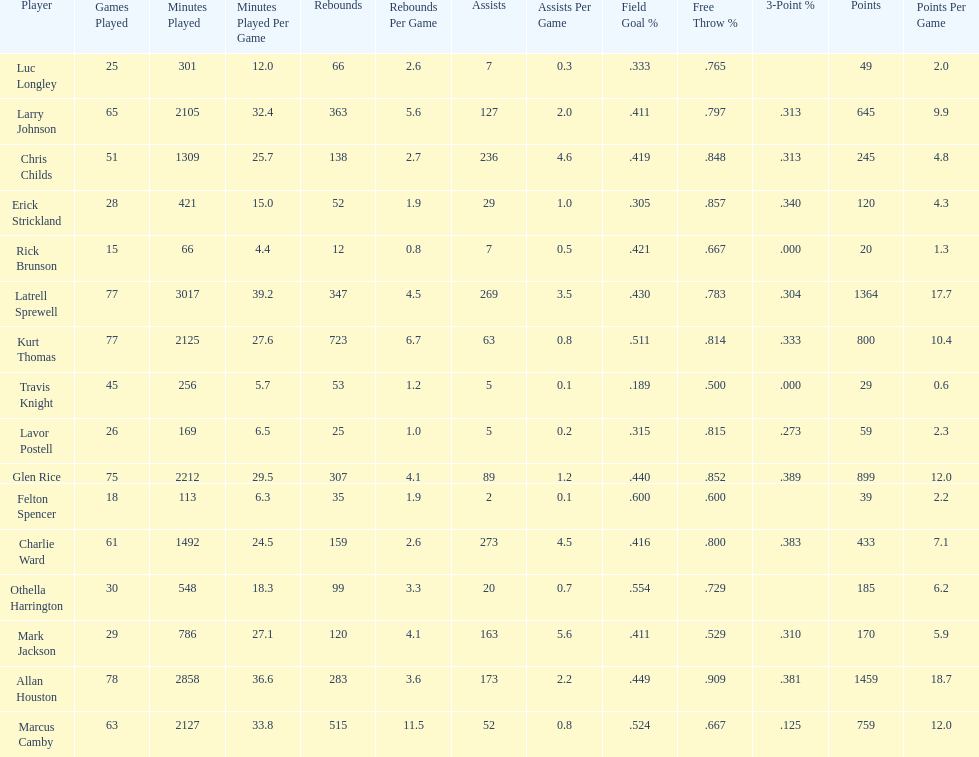How many more games did allan houston play than mark jackson? 49. 